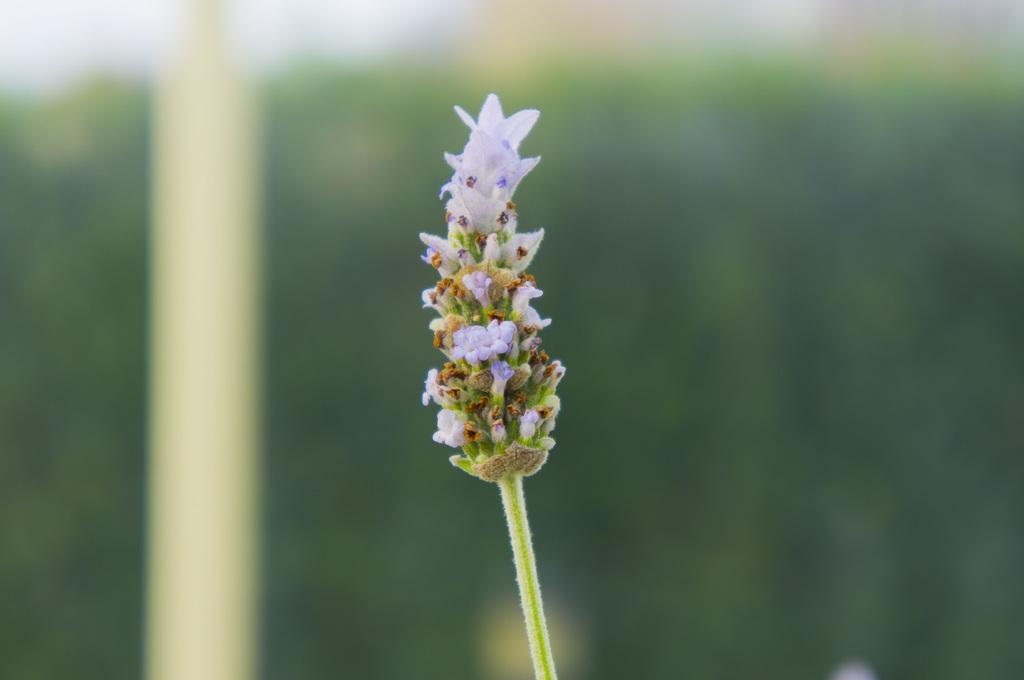What type of plants can be seen in the image? There are flowers in the image. Can you describe the stage of growth for some of the flowers? There are buds on a stem in the image. What is the appearance of the background in the image? The background of the image is blurred. What type of cord is connected to the rock in the image? There is no rock or cord present in the image. 